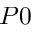<formula> <loc_0><loc_0><loc_500><loc_500>P 0</formula> 